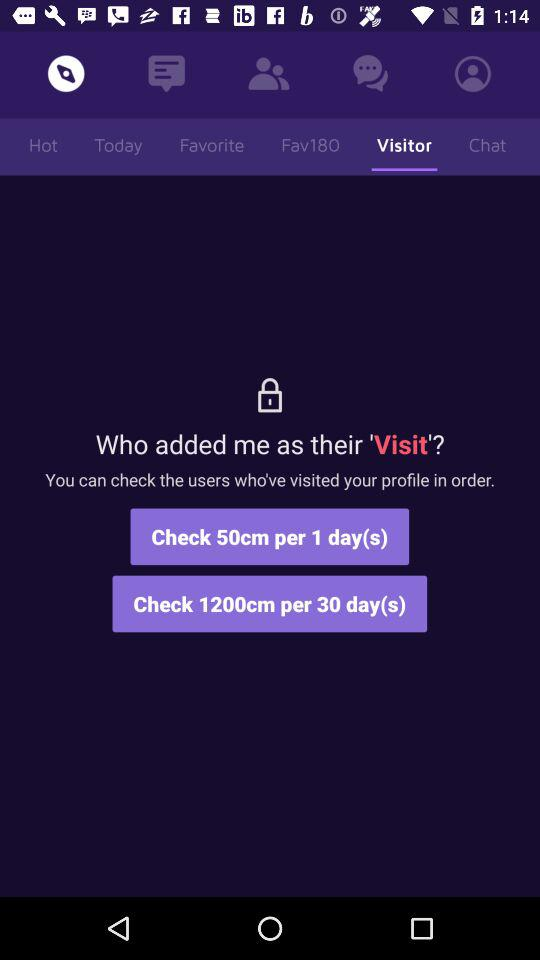How many more days does the 1200cm option cover than the 50cm option?
Answer the question using a single word or phrase. 29 